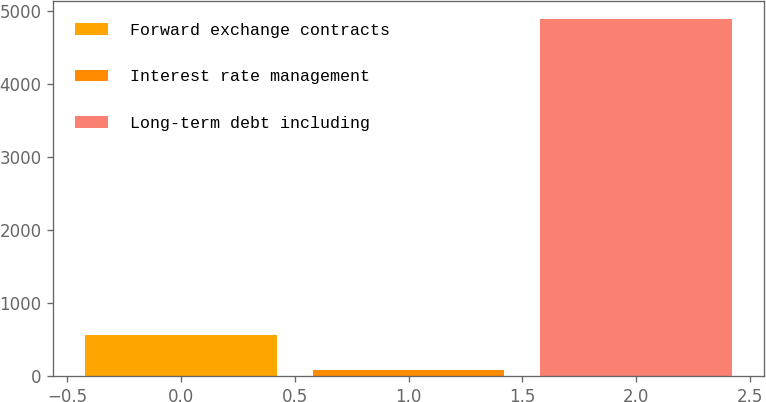Convert chart. <chart><loc_0><loc_0><loc_500><loc_500><bar_chart><fcel>Forward exchange contracts<fcel>Interest rate management<fcel>Long-term debt including<nl><fcel>559.45<fcel>78.3<fcel>4889.8<nl></chart> 